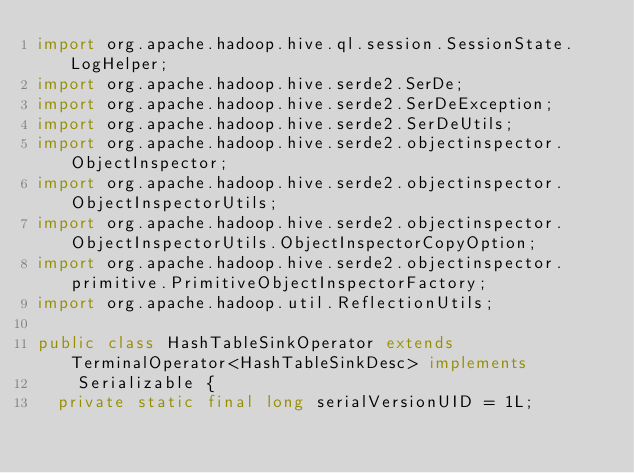<code> <loc_0><loc_0><loc_500><loc_500><_Java_>import org.apache.hadoop.hive.ql.session.SessionState.LogHelper;
import org.apache.hadoop.hive.serde2.SerDe;
import org.apache.hadoop.hive.serde2.SerDeException;
import org.apache.hadoop.hive.serde2.SerDeUtils;
import org.apache.hadoop.hive.serde2.objectinspector.ObjectInspector;
import org.apache.hadoop.hive.serde2.objectinspector.ObjectInspectorUtils;
import org.apache.hadoop.hive.serde2.objectinspector.ObjectInspectorUtils.ObjectInspectorCopyOption;
import org.apache.hadoop.hive.serde2.objectinspector.primitive.PrimitiveObjectInspectorFactory;
import org.apache.hadoop.util.ReflectionUtils;

public class HashTableSinkOperator extends TerminalOperator<HashTableSinkDesc> implements
    Serializable {
  private static final long serialVersionUID = 1L;</code> 